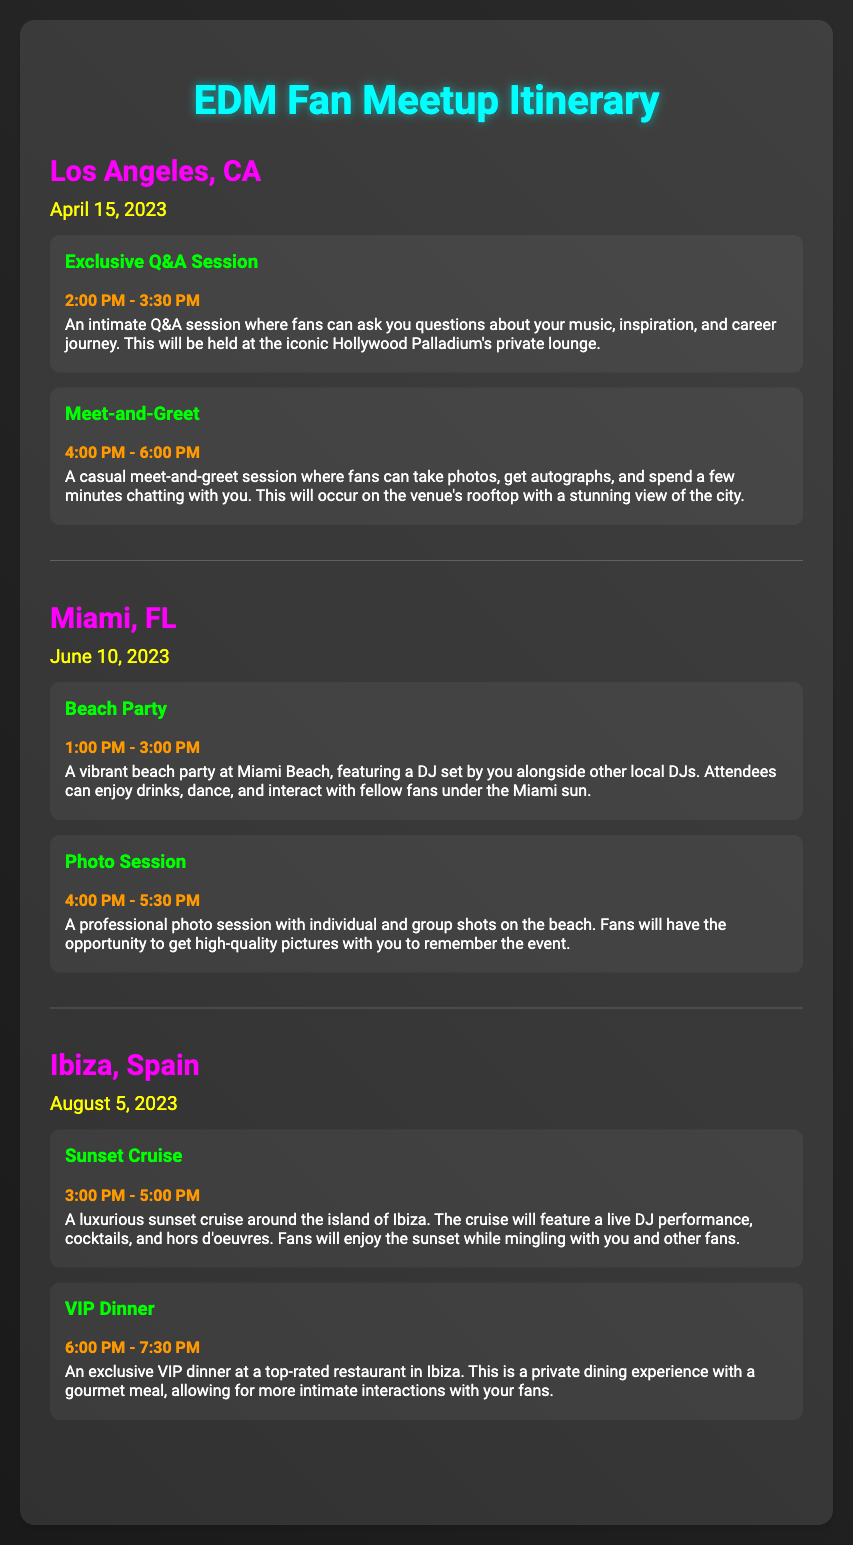what is the date of the Los Angeles meetup? The date of the Los Angeles meetup is specified in the document as April 15, 2023.
Answer: April 15, 2023 what activity is scheduled for 2:00 PM in Los Angeles? The activity scheduled for 2:00 PM in Los Angeles is an Exclusive Q&A Session.
Answer: Exclusive Q&A Session how long is the Miami Beach Party? The duration of the Miami Beach Party is from 1:00 PM to 3:00 PM, making it 2 hours long.
Answer: 2 hours which city has a VIP Dinner event? The city that has a VIP Dinner event is Ibiza, Spain.
Answer: Ibiza, Spain what time does the sunset cruise in Ibiza start? The sunset cruise in Ibiza starts at 3:00 PM, as stated in the document.
Answer: 3:00 PM how many activities are scheduled for the Miami event? The Miami event has two scheduled activities: Beach Party and Photo Session, as listed in the document.
Answer: Two what is the location of the meet-and-greet in Los Angeles? The meet-and-greet location in Los Angeles is on the venue's rooftop.
Answer: Rooftop when will the sunset cruise take place? The sunset cruise will take place on August 5, 2023, according to the document.
Answer: August 5, 2023 